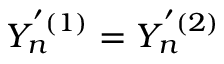Convert formula to latex. <formula><loc_0><loc_0><loc_500><loc_500>Y _ { n } ^ { ^ { \prime } ( 1 ) } = Y _ { n } ^ { ^ { \prime } ( 2 ) }</formula> 